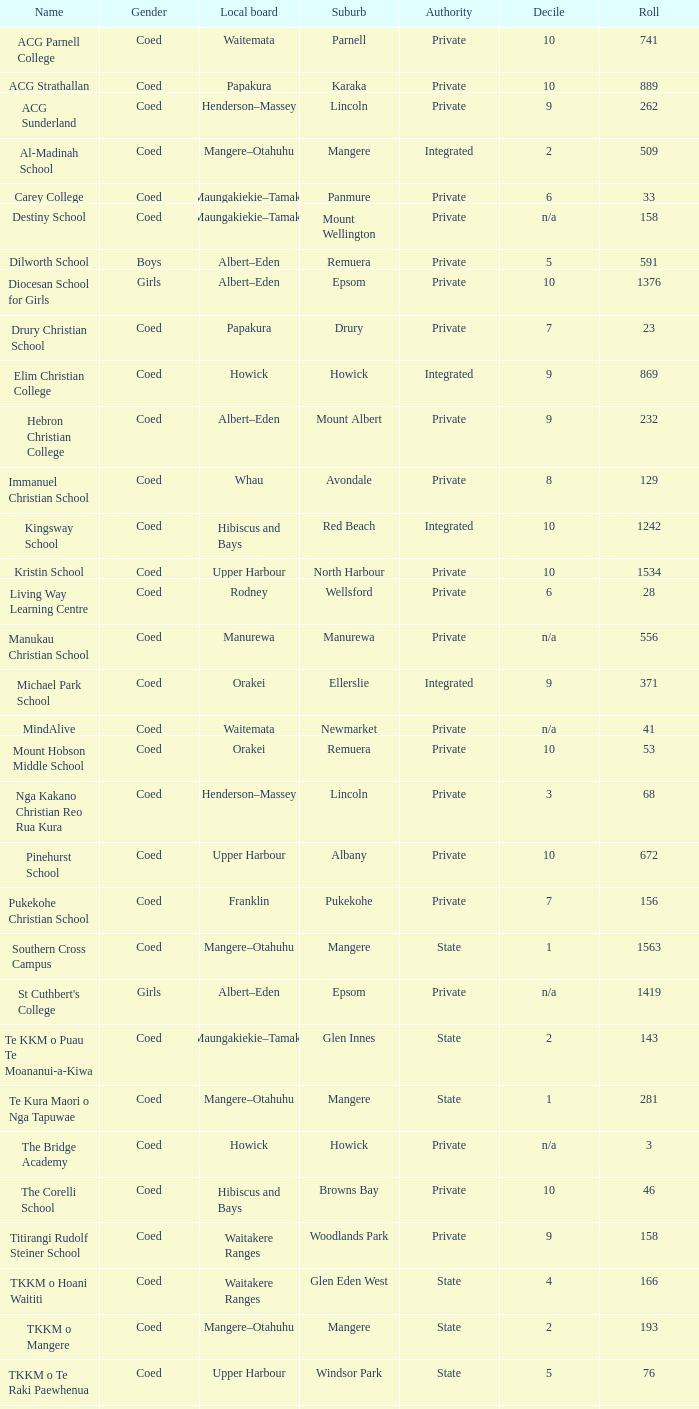What gender has a local board of albert–eden with a roll of more than 232 and Decile of 5? Boys. 